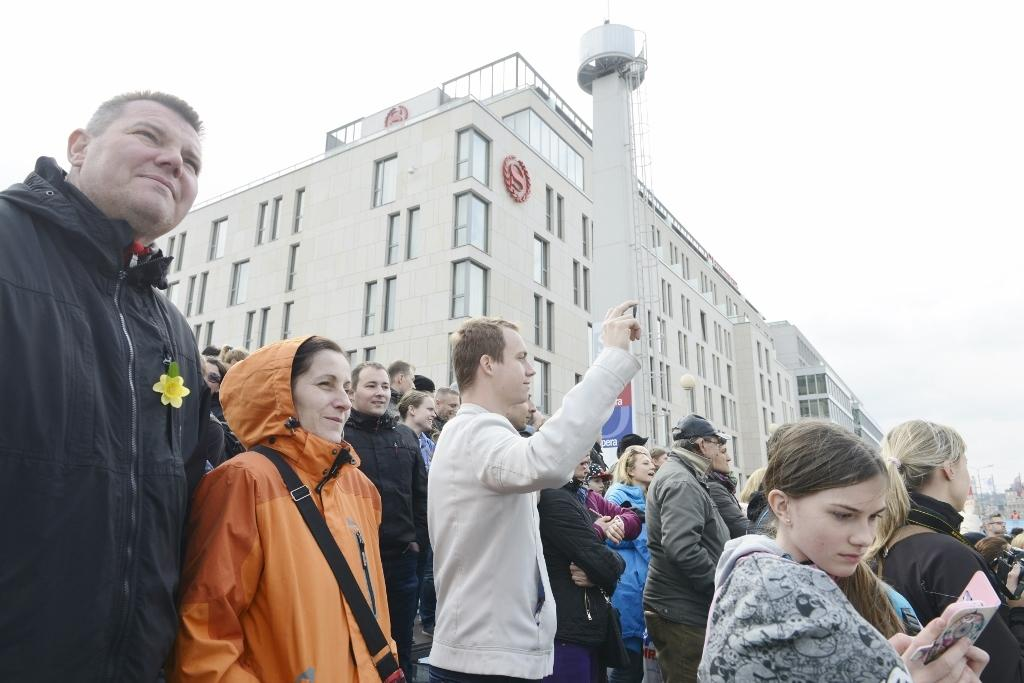What can be seen at the bottom of the image? There are people standing at the bottom of the image. What are the people holding in their hands? The people are holding something in their hands. What is visible behind the people? There are buildings behind the people. What is visible at the top of the image? The sky is visible at the top of the image. What type of territory is being claimed by the people in the image? There is no indication in the image that the people are claiming any territory. 